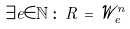<formula> <loc_0><loc_0><loc_500><loc_500>\exists e \in { \mathbb { N } } \, \colon \, R \, = \, { \mathcal { W } } _ { e } ^ { n }</formula> 